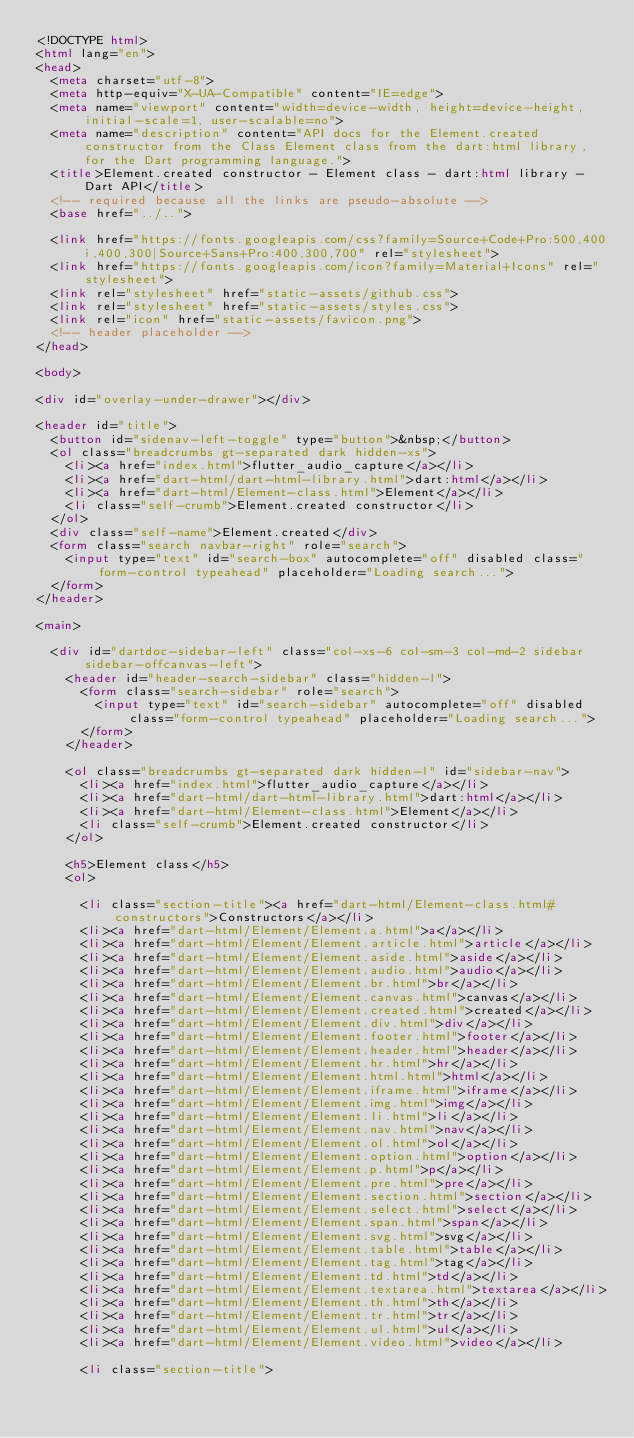Convert code to text. <code><loc_0><loc_0><loc_500><loc_500><_HTML_><!DOCTYPE html>
<html lang="en">
<head>
  <meta charset="utf-8">
  <meta http-equiv="X-UA-Compatible" content="IE=edge">
  <meta name="viewport" content="width=device-width, height=device-height, initial-scale=1, user-scalable=no">
  <meta name="description" content="API docs for the Element.created constructor from the Class Element class from the dart:html library, for the Dart programming language.">
  <title>Element.created constructor - Element class - dart:html library - Dart API</title>
  <!-- required because all the links are pseudo-absolute -->
  <base href="../..">

  <link href="https://fonts.googleapis.com/css?family=Source+Code+Pro:500,400i,400,300|Source+Sans+Pro:400,300,700" rel="stylesheet">
  <link href="https://fonts.googleapis.com/icon?family=Material+Icons" rel="stylesheet">
  <link rel="stylesheet" href="static-assets/github.css">
  <link rel="stylesheet" href="static-assets/styles.css">
  <link rel="icon" href="static-assets/favicon.png">
  <!-- header placeholder -->
</head>

<body>

<div id="overlay-under-drawer"></div>

<header id="title">
  <button id="sidenav-left-toggle" type="button">&nbsp;</button>
  <ol class="breadcrumbs gt-separated dark hidden-xs">
    <li><a href="index.html">flutter_audio_capture</a></li>
    <li><a href="dart-html/dart-html-library.html">dart:html</a></li>
    <li><a href="dart-html/Element-class.html">Element</a></li>
    <li class="self-crumb">Element.created constructor</li>
  </ol>
  <div class="self-name">Element.created</div>
  <form class="search navbar-right" role="search">
    <input type="text" id="search-box" autocomplete="off" disabled class="form-control typeahead" placeholder="Loading search...">
  </form>
</header>

<main>

  <div id="dartdoc-sidebar-left" class="col-xs-6 col-sm-3 col-md-2 sidebar sidebar-offcanvas-left">
    <header id="header-search-sidebar" class="hidden-l">
      <form class="search-sidebar" role="search">
        <input type="text" id="search-sidebar" autocomplete="off" disabled class="form-control typeahead" placeholder="Loading search...">
      </form>
    </header>
    
    <ol class="breadcrumbs gt-separated dark hidden-l" id="sidebar-nav">
      <li><a href="index.html">flutter_audio_capture</a></li>
      <li><a href="dart-html/dart-html-library.html">dart:html</a></li>
      <li><a href="dart-html/Element-class.html">Element</a></li>
      <li class="self-crumb">Element.created constructor</li>
    </ol>
    
    <h5>Element class</h5>
    <ol>
    
      <li class="section-title"><a href="dart-html/Element-class.html#constructors">Constructors</a></li>
      <li><a href="dart-html/Element/Element.a.html">a</a></li>
      <li><a href="dart-html/Element/Element.article.html">article</a></li>
      <li><a href="dart-html/Element/Element.aside.html">aside</a></li>
      <li><a href="dart-html/Element/Element.audio.html">audio</a></li>
      <li><a href="dart-html/Element/Element.br.html">br</a></li>
      <li><a href="dart-html/Element/Element.canvas.html">canvas</a></li>
      <li><a href="dart-html/Element/Element.created.html">created</a></li>
      <li><a href="dart-html/Element/Element.div.html">div</a></li>
      <li><a href="dart-html/Element/Element.footer.html">footer</a></li>
      <li><a href="dart-html/Element/Element.header.html">header</a></li>
      <li><a href="dart-html/Element/Element.hr.html">hr</a></li>
      <li><a href="dart-html/Element/Element.html.html">html</a></li>
      <li><a href="dart-html/Element/Element.iframe.html">iframe</a></li>
      <li><a href="dart-html/Element/Element.img.html">img</a></li>
      <li><a href="dart-html/Element/Element.li.html">li</a></li>
      <li><a href="dart-html/Element/Element.nav.html">nav</a></li>
      <li><a href="dart-html/Element/Element.ol.html">ol</a></li>
      <li><a href="dart-html/Element/Element.option.html">option</a></li>
      <li><a href="dart-html/Element/Element.p.html">p</a></li>
      <li><a href="dart-html/Element/Element.pre.html">pre</a></li>
      <li><a href="dart-html/Element/Element.section.html">section</a></li>
      <li><a href="dart-html/Element/Element.select.html">select</a></li>
      <li><a href="dart-html/Element/Element.span.html">span</a></li>
      <li><a href="dart-html/Element/Element.svg.html">svg</a></li>
      <li><a href="dart-html/Element/Element.table.html">table</a></li>
      <li><a href="dart-html/Element/Element.tag.html">tag</a></li>
      <li><a href="dart-html/Element/Element.td.html">td</a></li>
      <li><a href="dart-html/Element/Element.textarea.html">textarea</a></li>
      <li><a href="dart-html/Element/Element.th.html">th</a></li>
      <li><a href="dart-html/Element/Element.tr.html">tr</a></li>
      <li><a href="dart-html/Element/Element.ul.html">ul</a></li>
      <li><a href="dart-html/Element/Element.video.html">video</a></li>
    
      <li class="section-title"></code> 